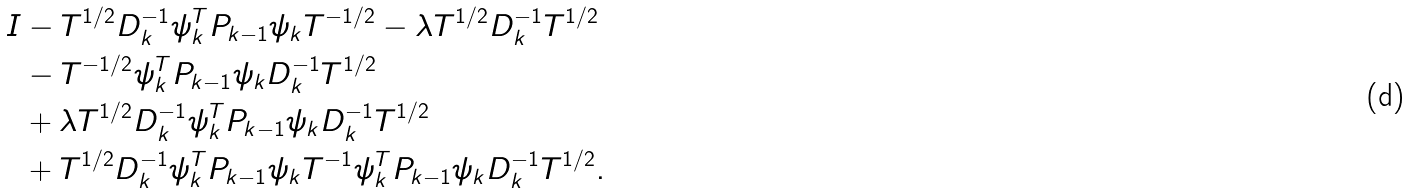<formula> <loc_0><loc_0><loc_500><loc_500>I & - T ^ { 1 / 2 } D _ { k } ^ { - 1 } \psi _ { k } ^ { T } P _ { k - 1 } \psi _ { k } T ^ { - 1 / 2 } - \lambda T ^ { 1 / 2 } D _ { k } ^ { - 1 } T ^ { 1 / 2 } \\ & - T ^ { - 1 / 2 } \psi _ { k } ^ { T } P _ { k - 1 } \psi _ { k } D _ { k } ^ { - 1 } T ^ { 1 / 2 } \\ & + \lambda T ^ { 1 / 2 } D _ { k } ^ { - 1 } \psi _ { k } ^ { T } P _ { k - 1 } \psi _ { k } D _ { k } ^ { - 1 } T ^ { 1 / 2 } \\ & + T ^ { 1 / 2 } D _ { k } ^ { - 1 } \psi _ { k } ^ { T } P _ { k - 1 } \psi _ { k } T ^ { - 1 } \psi _ { k } ^ { T } P _ { k - 1 } \psi _ { k } D _ { k } ^ { - 1 } T ^ { 1 / 2 } .</formula> 